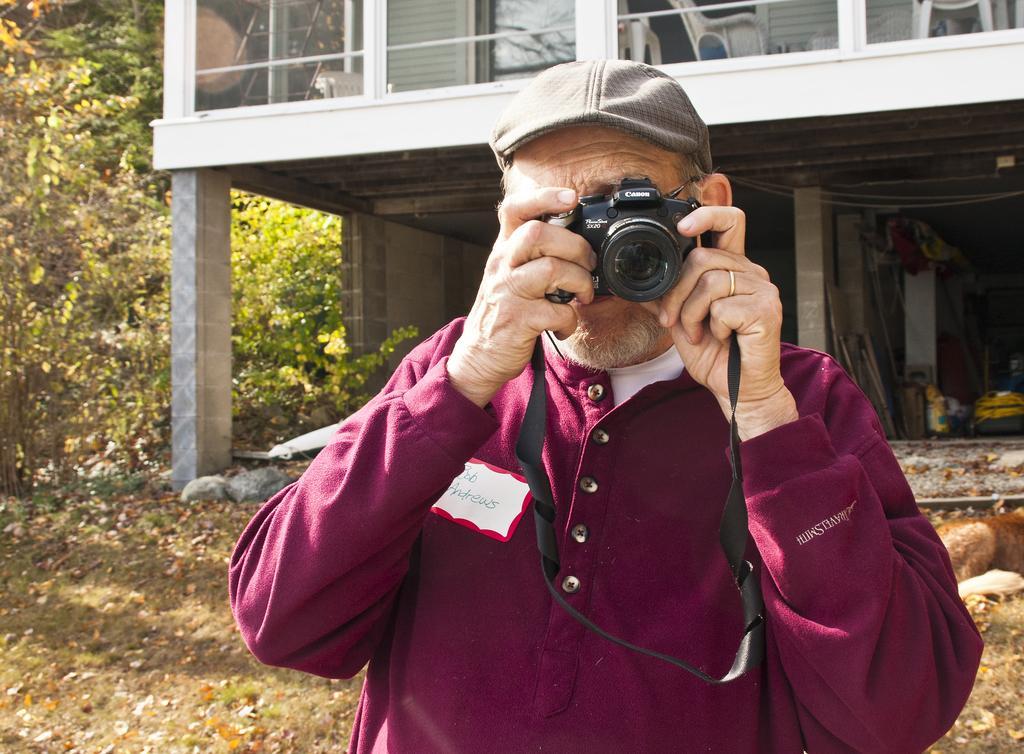How would you summarize this image in a sentence or two? The person is holding a camera and wire cap. This is a house with windows. These are plants and trees. 